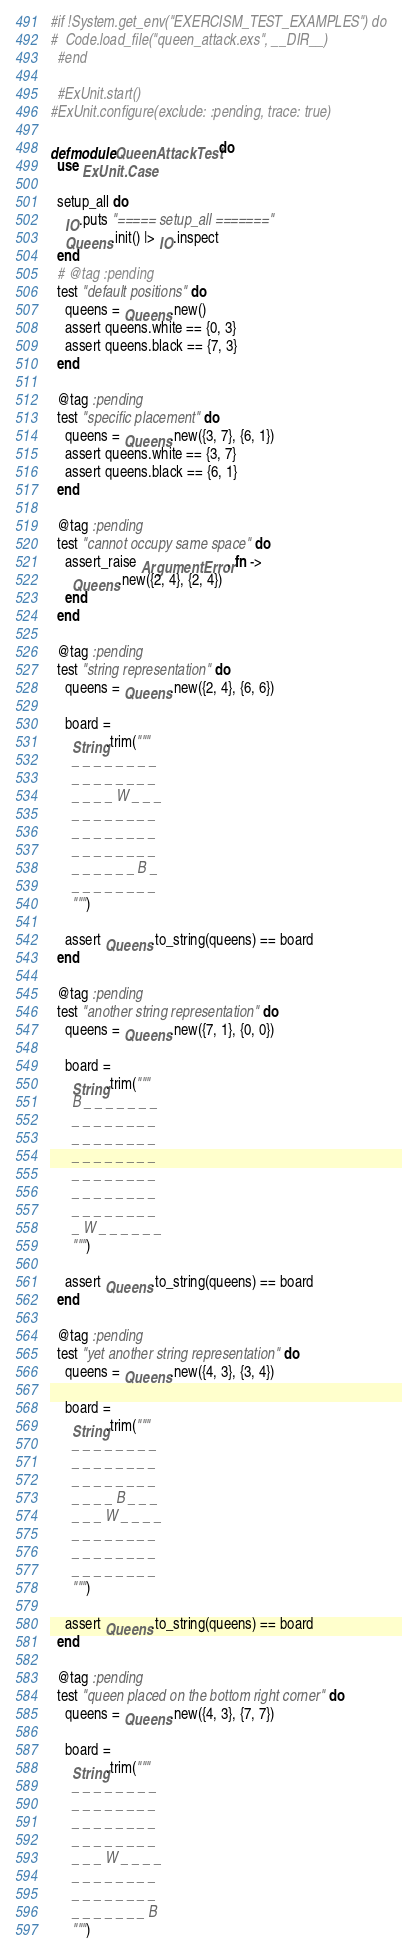<code> <loc_0><loc_0><loc_500><loc_500><_Elixir_>#if !System.get_env("EXERCISM_TEST_EXAMPLES") do
#  Code.load_file("queen_attack.exs", __DIR__)
  #end

  #ExUnit.start()
#ExUnit.configure(exclude: :pending, trace: true)

defmodule QueenAttackTest do
  use ExUnit.Case

  setup_all do
    IO.puts "===== setup_all ======="
    Queens.init() |> IO.inspect
  end
  # @tag :pending
  test "default positions" do
    queens = Queens.new()
    assert queens.white == {0, 3}
    assert queens.black == {7, 3}
  end

  @tag :pending
  test "specific placement" do
    queens = Queens.new({3, 7}, {6, 1})
    assert queens.white == {3, 7}
    assert queens.black == {6, 1}
  end

  @tag :pending
  test "cannot occupy same space" do
    assert_raise ArgumentError, fn ->
      Queens.new({2, 4}, {2, 4})
    end
  end

  @tag :pending
  test "string representation" do
    queens = Queens.new({2, 4}, {6, 6})

    board =
      String.trim("""
      _ _ _ _ _ _ _ _
      _ _ _ _ _ _ _ _
      _ _ _ _ W _ _ _
      _ _ _ _ _ _ _ _
      _ _ _ _ _ _ _ _
      _ _ _ _ _ _ _ _
      _ _ _ _ _ _ B _
      _ _ _ _ _ _ _ _
      """)

    assert Queens.to_string(queens) == board
  end

  @tag :pending
  test "another string representation" do
    queens = Queens.new({7, 1}, {0, 0})

    board =
      String.trim("""
      B _ _ _ _ _ _ _
      _ _ _ _ _ _ _ _
      _ _ _ _ _ _ _ _
      _ _ _ _ _ _ _ _
      _ _ _ _ _ _ _ _
      _ _ _ _ _ _ _ _
      _ _ _ _ _ _ _ _
      _ W _ _ _ _ _ _
      """)

    assert Queens.to_string(queens) == board
  end

  @tag :pending
  test "yet another string representation" do
    queens = Queens.new({4, 3}, {3, 4})

    board =
      String.trim("""
      _ _ _ _ _ _ _ _
      _ _ _ _ _ _ _ _
      _ _ _ _ _ _ _ _
      _ _ _ _ B _ _ _
      _ _ _ W _ _ _ _
      _ _ _ _ _ _ _ _
      _ _ _ _ _ _ _ _
      _ _ _ _ _ _ _ _
      """)

    assert Queens.to_string(queens) == board
  end

  @tag :pending
  test "queen placed on the bottom right corner" do
    queens = Queens.new({4, 3}, {7, 7})

    board =
      String.trim("""
      _ _ _ _ _ _ _ _
      _ _ _ _ _ _ _ _
      _ _ _ _ _ _ _ _
      _ _ _ _ _ _ _ _
      _ _ _ W _ _ _ _
      _ _ _ _ _ _ _ _
      _ _ _ _ _ _ _ _
      _ _ _ _ _ _ _ B
      """)
</code> 